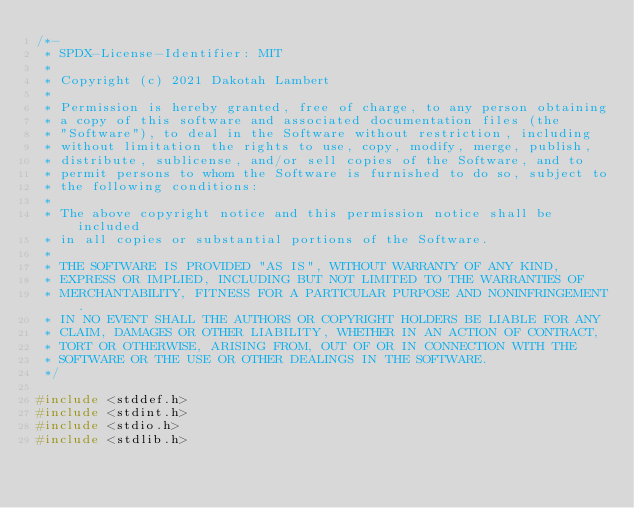<code> <loc_0><loc_0><loc_500><loc_500><_C_>/*-
 * SPDX-License-Identifier: MIT
 *
 * Copyright (c) 2021 Dakotah Lambert
 *
 * Permission is hereby granted, free of charge, to any person obtaining
 * a copy of this software and associated documentation files (the
 * "Software"), to deal in the Software without restriction, including
 * without limitation the rights to use, copy, modify, merge, publish,
 * distribute, sublicense, and/or sell copies of the Software, and to
 * permit persons to whom the Software is furnished to do so, subject to
 * the following conditions:
 *
 * The above copyright notice and this permission notice shall be included
 * in all copies or substantial portions of the Software.
 *
 * THE SOFTWARE IS PROVIDED "AS IS", WITHOUT WARRANTY OF ANY KIND,
 * EXPRESS OR IMPLIED, INCLUDING BUT NOT LIMITED TO THE WARRANTIES OF
 * MERCHANTABILITY, FITNESS FOR A PARTICULAR PURPOSE AND NONINFRINGEMENT.
 * IN NO EVENT SHALL THE AUTHORS OR COPYRIGHT HOLDERS BE LIABLE FOR ANY
 * CLAIM, DAMAGES OR OTHER LIABILITY, WHETHER IN AN ACTION OF CONTRACT,
 * TORT OR OTHERWISE, ARISING FROM, OUT OF OR IN CONNECTION WITH THE
 * SOFTWARE OR THE USE OR OTHER DEALINGS IN THE SOFTWARE.
 */

#include <stddef.h>
#include <stdint.h>
#include <stdio.h>
#include <stdlib.h></code> 